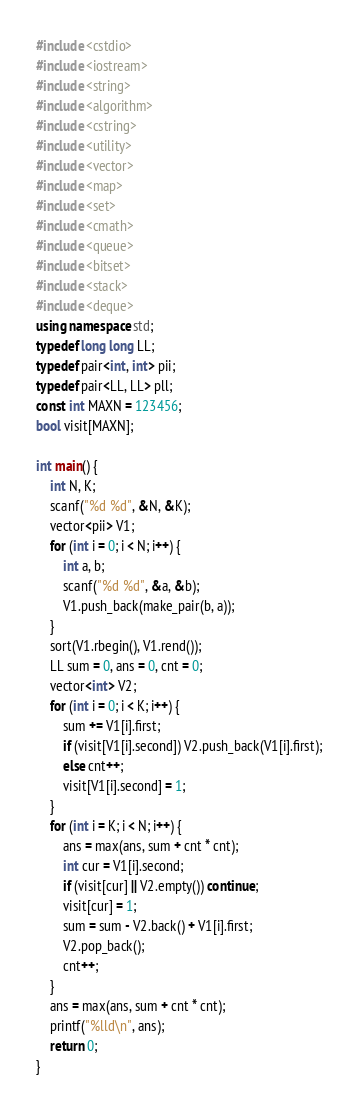<code> <loc_0><loc_0><loc_500><loc_500><_C++_>#include <cstdio>
#include <iostream>
#include <string>
#include <algorithm>
#include <cstring>
#include <utility>
#include <vector>
#include <map>
#include <set>
#include <cmath>
#include <queue>
#include <bitset>
#include <stack>
#include <deque>
using namespace std;
typedef long long LL;
typedef pair<int, int> pii;
typedef pair<LL, LL> pll;
const int MAXN = 123456;
bool visit[MAXN];

int main() {
    int N, K;
    scanf("%d %d", &N, &K);
    vector<pii> V1;
    for (int i = 0; i < N; i++) {
        int a, b;
        scanf("%d %d", &a, &b);
        V1.push_back(make_pair(b, a));
    }
    sort(V1.rbegin(), V1.rend());
    LL sum = 0, ans = 0, cnt = 0;
    vector<int> V2;
    for (int i = 0; i < K; i++) {
        sum += V1[i].first;
        if (visit[V1[i].second]) V2.push_back(V1[i].first);
        else cnt++;
        visit[V1[i].second] = 1;
    }
    for (int i = K; i < N; i++) {
        ans = max(ans, sum + cnt * cnt);
        int cur = V1[i].second;
        if (visit[cur] || V2.empty()) continue;
        visit[cur] = 1;
        sum = sum - V2.back() + V1[i].first;
        V2.pop_back();
        cnt++;
    }
    ans = max(ans, sum + cnt * cnt);
    printf("%lld\n", ans);
    return 0;
}
</code> 